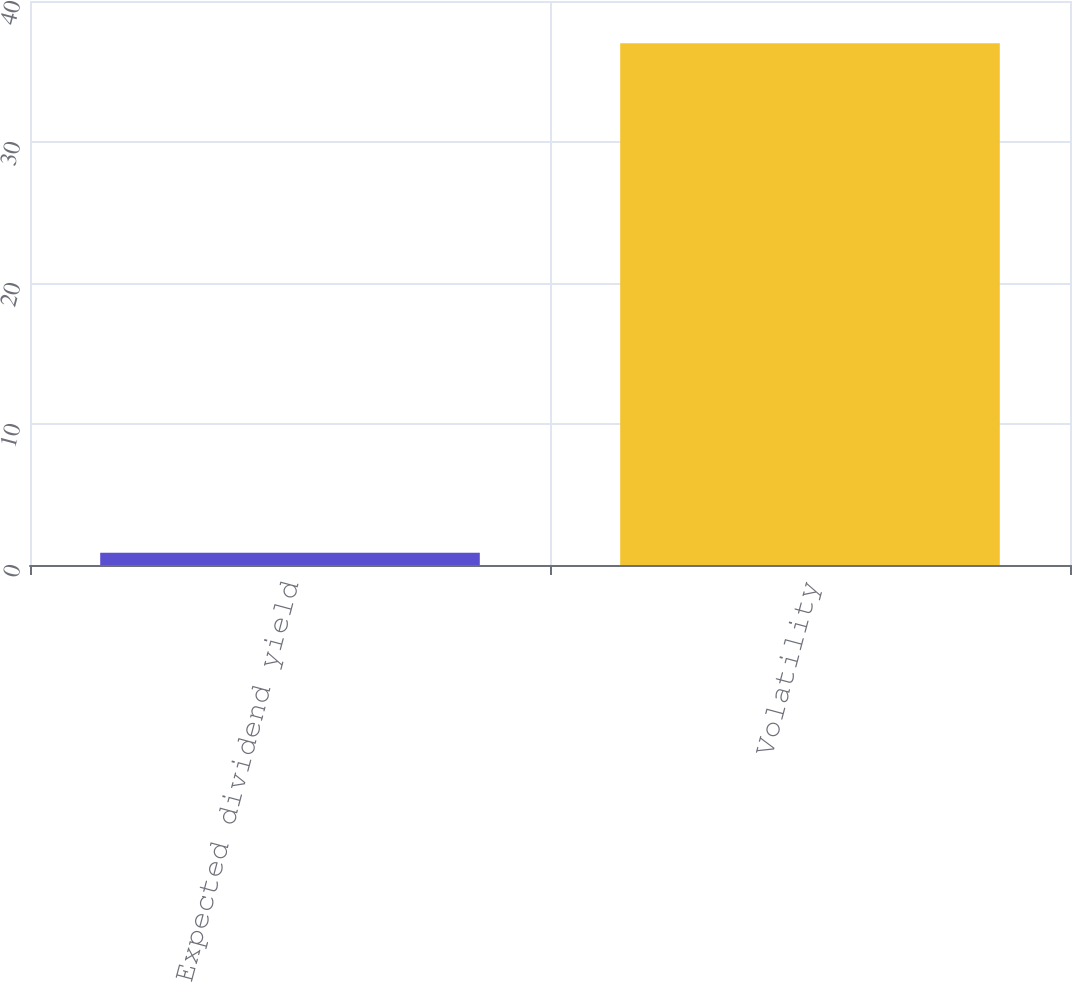Convert chart. <chart><loc_0><loc_0><loc_500><loc_500><bar_chart><fcel>Expected dividend yield<fcel>Volatility<nl><fcel>0.86<fcel>37<nl></chart> 